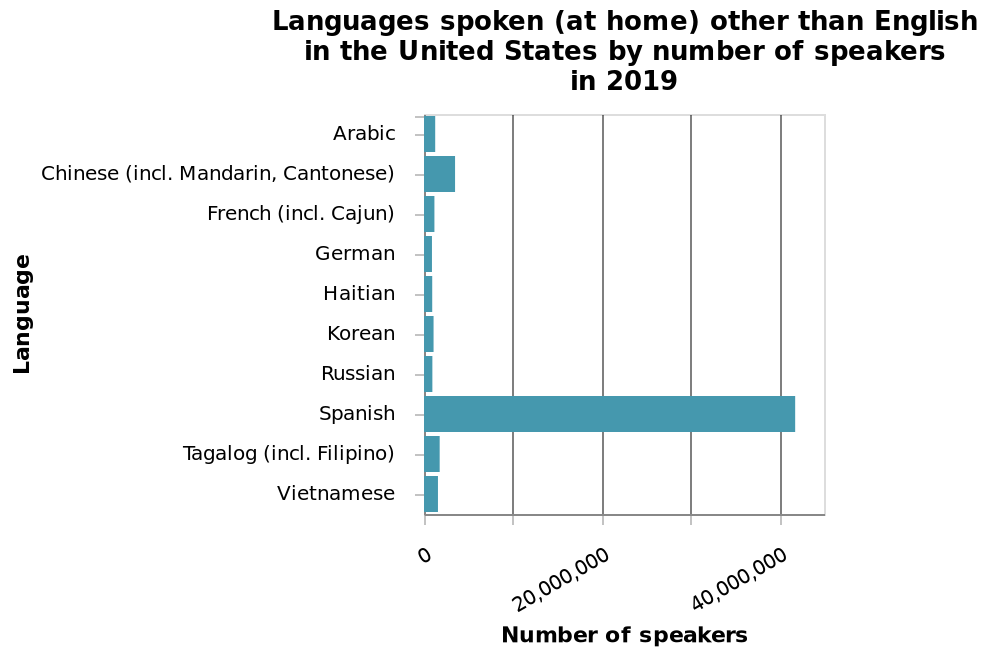<image>
What does the y-axis represent on the bar chart?  The y-axis represents different languages spoken at home other than English in the United States, plotted on a categorical scale starting from Arabic and ending at [unmentioned language]. Describe the following image in detail Here a is a bar chart labeled Languages spoken (at home) other than English in the United States by number of speakers in 2019. The x-axis shows Number of speakers as linear scale from 0 to 40,000,000 while the y-axis plots Language along categorical scale starting at Arabic and ending at . 